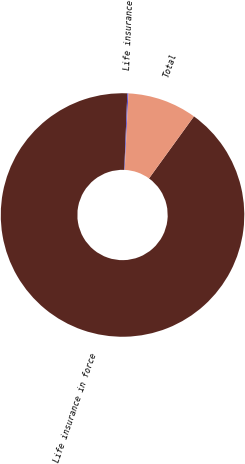Convert chart. <chart><loc_0><loc_0><loc_500><loc_500><pie_chart><fcel>Life insurance in force<fcel>Life insurance<fcel>Total<nl><fcel>90.66%<fcel>0.15%<fcel>9.2%<nl></chart> 